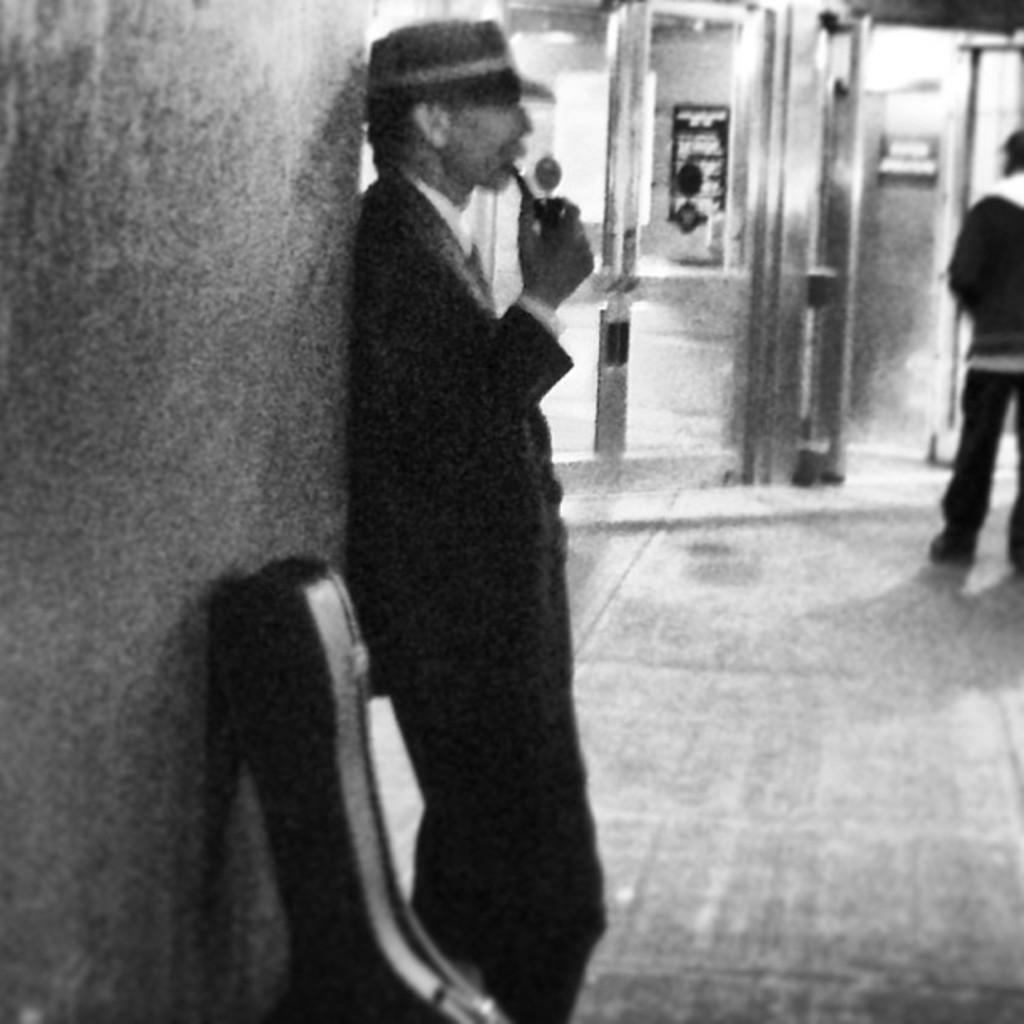Who is present in the image? There is a man in the image. What is the man wearing? The man is wearing a black suit. What can be seen to the left of the man? There is a wall to the left of the man. What is at the bottom of the image? There is a floor at the bottom of the image. What architectural features can be seen in the background? There are doors in the background of the image. What type of lunch is the man eating in the image? There is no indication of the man eating lunch in the image. What color is the yarn used to knit the man's suit? The man's suit is not made of yarn, and therefore the color of the yarn cannot be determined. 